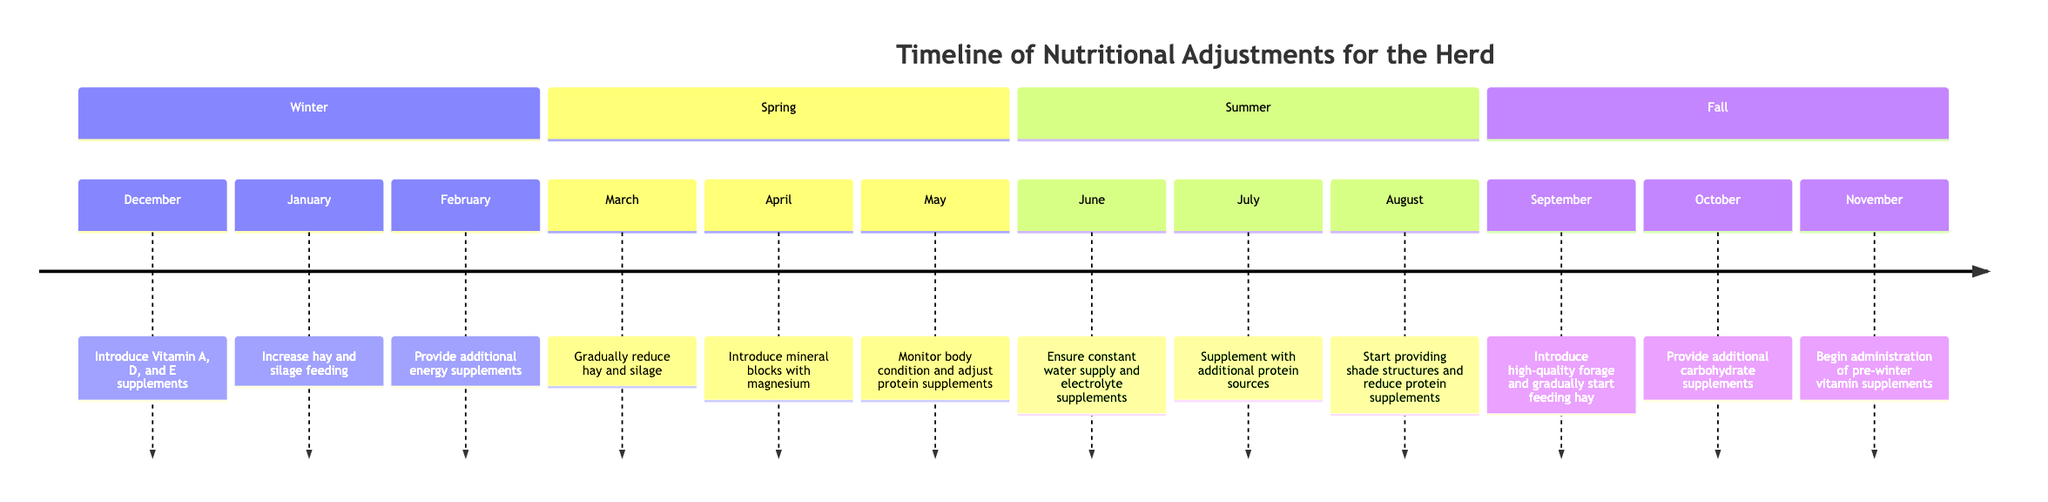What actions are taken in February during Winter? The diagram shows that in February, the action taken is "Provide additional energy supplements such as corn." This information can be found by looking at the Winter section and the specific month of February.
Answer: Provide additional energy supplements such as corn How many tasks are listed for Spring? By examining the Spring section of the diagram, we can count three tasks: March (Gradually reduce hay and silage), April (Introduce mineral blocks with magnesium), and May (Monitor body condition and adjust protein supplements). Therefore, there are three tasks in total.
Answer: 3 What is introduced in April? In the April section of the Spring tasks, the action listed is "Introduce mineral blocks with magnesium." This is a straightforward retrieval from the diagram for that specific month.
Answer: Introduce mineral blocks with magnesium What is the reason for introducing Vitamin A, D, and E supplements in December? The diagram specifies that the reason for introducing Vitamin A, D, and E supplements in December is due to "Reduced sunlight and lower forage quality." This is located in the Winter section under December.
Answer: Reduced sunlight and lower forage quality Which supplement is provided in October? In October, the action mentioned in the Fall section is "Provide additional carbohydrate supplements." This information can be extracted directly from the timeline's October task.
Answer: Provide additional carbohydrate supplements What is the common reason for monitoring body condition in May? The diagram explicitly indicates that the reason for monitoring body condition and adjusting protein supplements in May is to "Compensate for variable forage quality." This requires referencing both the task and its reason within the Spring section.
Answer: Compensate for variable forage quality During which month is shade provided for the herd? According to the Summer section in August, the action is "Start providing shade structures and reduce protein supplements." This indicates that the shade provision takes place in August.
Answer: August What are the main adjustments made to the herd's diet in Summer? Summarizing from the Summer section, the main adjustments include ensuring constant water supply and electrolyte supplements in June, supplementing with additional protein sources in July, and starting to provide shade while reducing protein supplements in August. Thus, there are multiple dietary adjustments in this season.
Answer: Ensure constant water supply and electrolyte supplements; Supplement with additional protein sources; Start providing shade structures and reduce protein supplements What specific nutrients are supplemented in Winter? In the Winter section, the specific nutrients supplemented throughout December to February include Vitamin A, D, E, and additional energy supplements like corn in February. This is a summary of the key actions taken during Winter regarding nutrients.
Answer: Vitamin A, D, E, and additional energy supplements like corn 